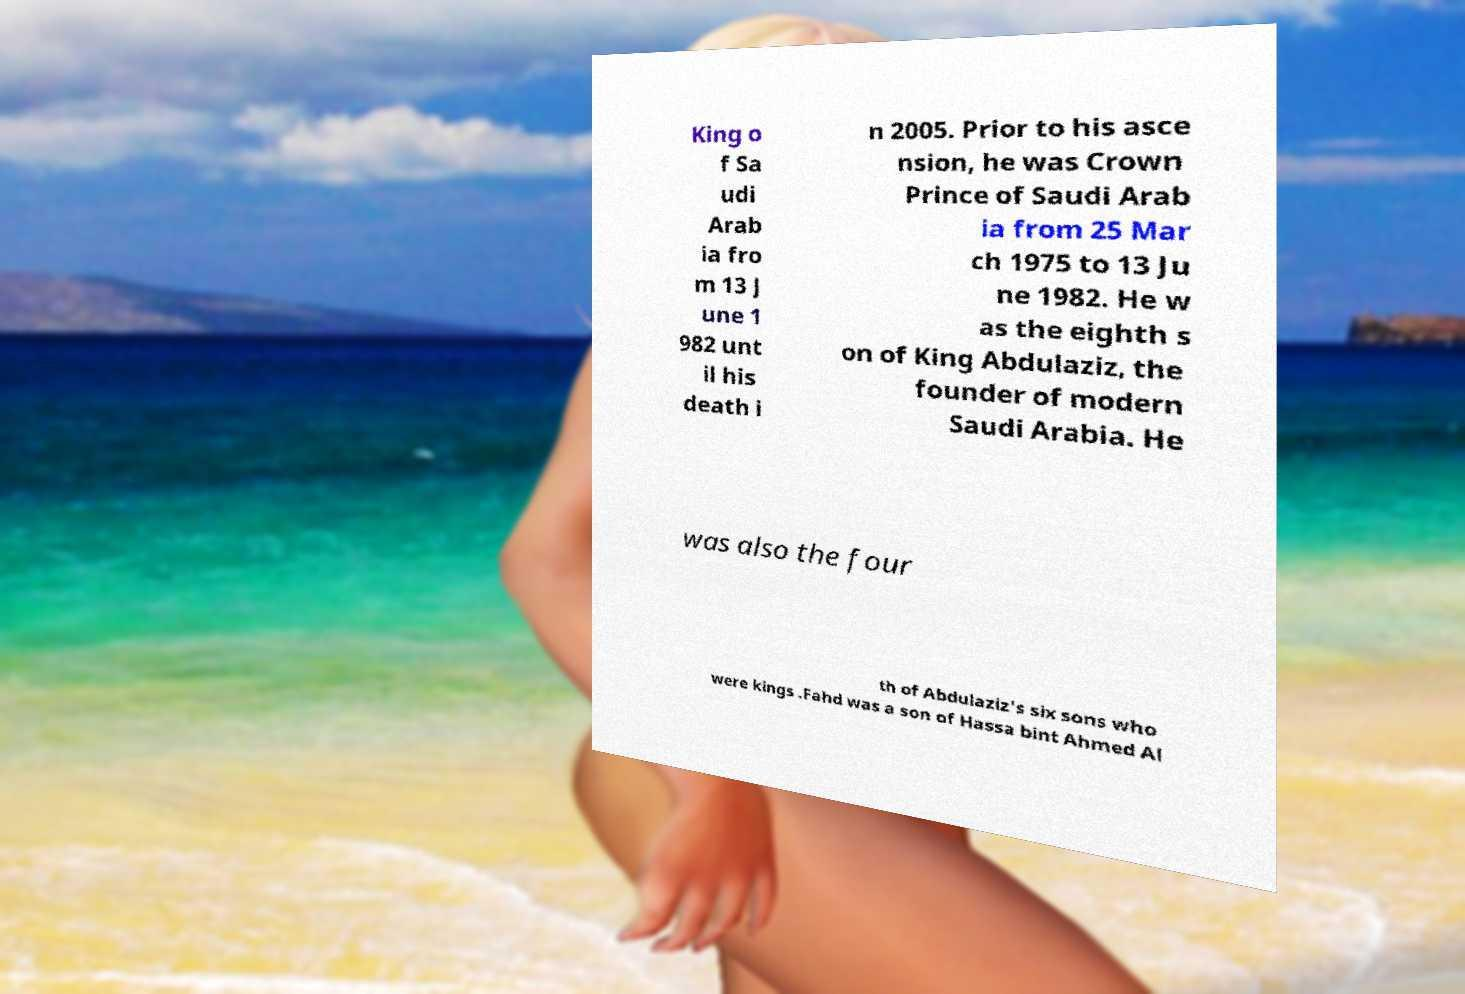What messages or text are displayed in this image? I need them in a readable, typed format. King o f Sa udi Arab ia fro m 13 J une 1 982 unt il his death i n 2005. Prior to his asce nsion, he was Crown Prince of Saudi Arab ia from 25 Mar ch 1975 to 13 Ju ne 1982. He w as the eighth s on of King Abdulaziz, the founder of modern Saudi Arabia. He was also the four th of Abdulaziz's six sons who were kings .Fahd was a son of Hassa bint Ahmed Al 